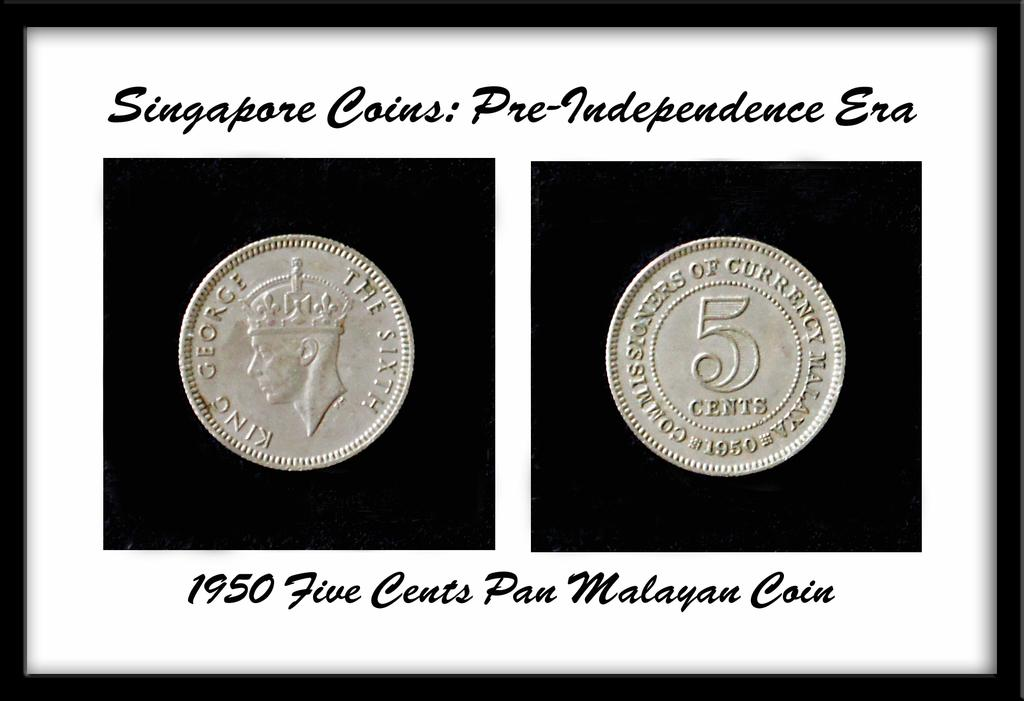<image>
Present a compact description of the photo's key features. Two coins sit in a decorative box from the pre-independence era. 